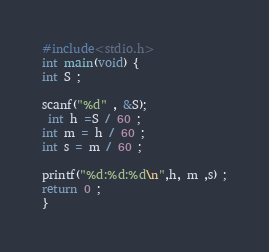Convert code to text. <code><loc_0><loc_0><loc_500><loc_500><_C_>#include<stdio.h>
int main(void) {
int S ;

scanf("%d" , &S);
 int h =S / 60 ;
int m = h / 60 ;
int s = m / 60 ;

printf("%d:%d:%d\n",h, m ,s) ;
return 0 ;
}</code> 